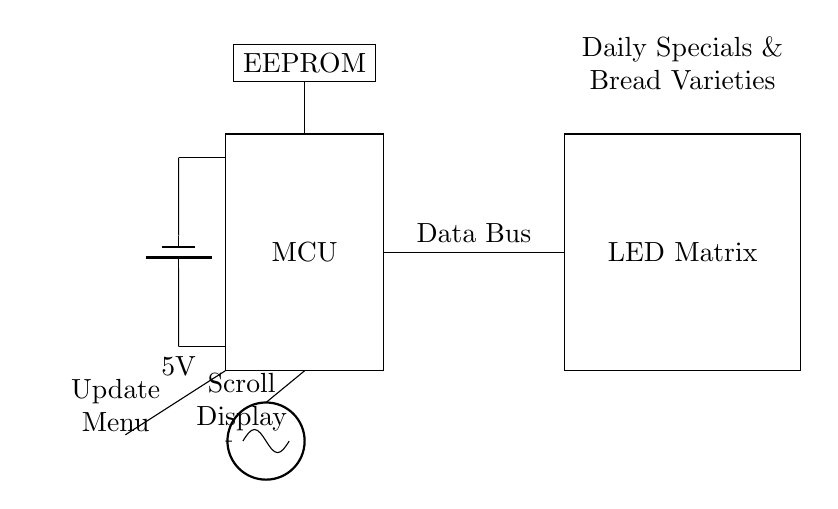What is the main component of this circuit? The main component, or the heart of the circuit, is the microcontroller, which processes input and controls the LED Matrix.
Answer: Microcontroller What is the purpose of the EEPROM in this circuit? The EEPROM is used for storing the daily specials and bread varieties that the microcontroller retrieves and displays on the LED Matrix.
Answer: Storage How many buttons are present in the circuit? There are two buttons connected to the microcontroller for user interaction: one for updating the menu and another for scrolling the display.
Answer: Two What is the voltage supply for this circuit? The circuit uses a 5V power supply, as indicated by the battery symbol connected to the microcontroller.
Answer: 5V What type of display is used in this circuit? The display used in this circuit is an LED Matrix, which is capable of showing multiple characters and graphics for the daily specials.
Answer: LED Matrix How does the microcontroller receive data to display on the LED Matrix? The microcontroller receives data through the data bus from the stored information in the EEPROM, allowing it to send the relevant signals to the LED Matrix for display.
Answer: Data bus What role does the clock play in this circuit? The clock provides timing signals to the microcontroller, ensuring that operations and data transfers occur in a synchronized manner, which is critical for time-sensitive tasks.
Answer: Synchronization 